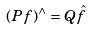Convert formula to latex. <formula><loc_0><loc_0><loc_500><loc_500>( P f ) ^ { \wedge } = Q \hat { f }</formula> 